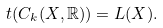Convert formula to latex. <formula><loc_0><loc_0><loc_500><loc_500>t ( C _ { k } ( X , \mathbb { R } ) ) = L ( X ) .</formula> 